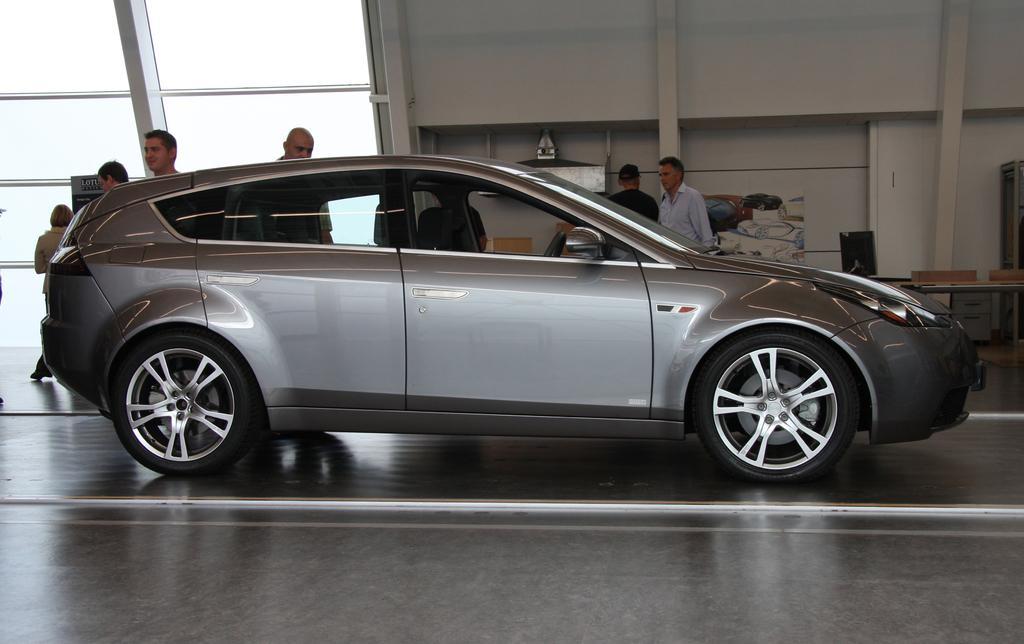Could you give a brief overview of what you see in this image? There is a grey color car and there are few people standing beside it. 